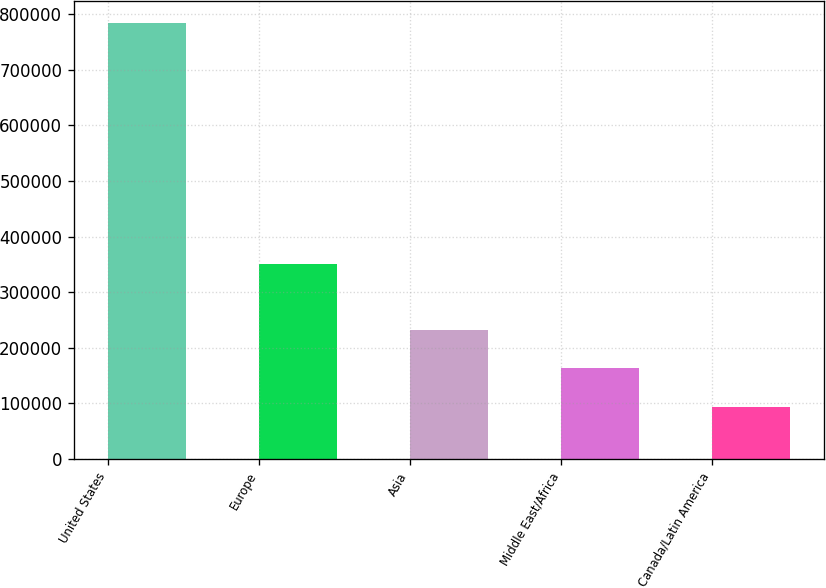<chart> <loc_0><loc_0><loc_500><loc_500><bar_chart><fcel>United States<fcel>Europe<fcel>Asia<fcel>Middle East/Africa<fcel>Canada/Latin America<nl><fcel>783685<fcel>350118<fcel>231963<fcel>162997<fcel>94032<nl></chart> 